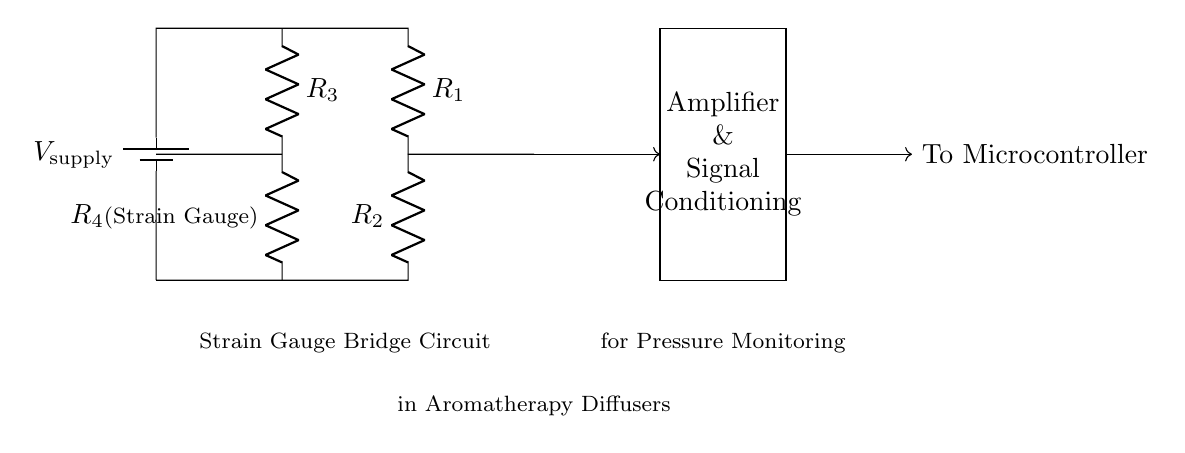What type of circuit is this? This is a strain gauge bridge circuit, which is used to measure changes in resistance caused by strain, primarily in this context for monitoring pressure.
Answer: Strain gauge bridge What is the purpose of R4? R4, marked as the strain gauge, is crucial for measuring the deformation that occurs under pressure, thus changing its resistance, which is central to how the bridge operates.
Answer: Strain gauge What do the arrows indicate in the diagram? The arrows in the diagram represent the direction of current flow. It shows how electrical signals are processed through the circuit, leading to the output for monitoring purposes.
Answer: Current direction How many resistors are present in this circuit? There are four resistors labeled as R1, R2, R3, and R4, with R4 being the strain gauge. Each resistor plays a role in creating the resistive network necessary for the strain gauge bridge function.
Answer: Four What comes after the amplifier in the circuit? After the amplifier, the signal is sent to the microcontroller for further processing. This highlights the importance of signal conditioning to enhance the output for effective monitoring.
Answer: To microcontroller What is the function of the amplifier in this circuit? The amplifier boosts the signal from the strain gauge bridge, allowing for stronger and clearer signals to be processed, which is essential for accurate pressure monitoring in the diffuser system.
Answer: Signal conditioning 